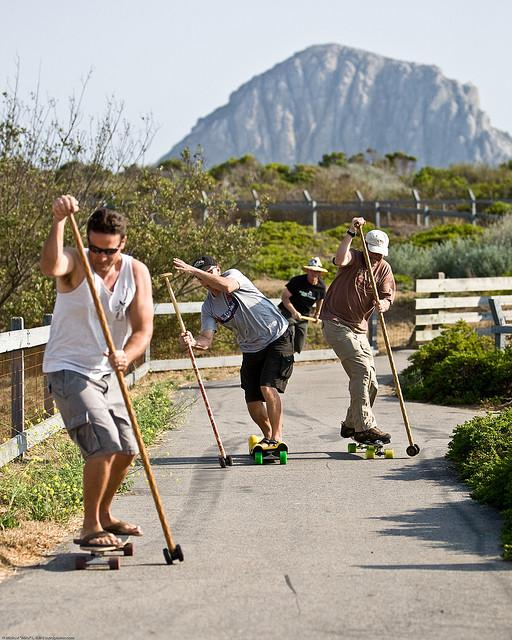What are the men doing with the large wooden poles? pushing 